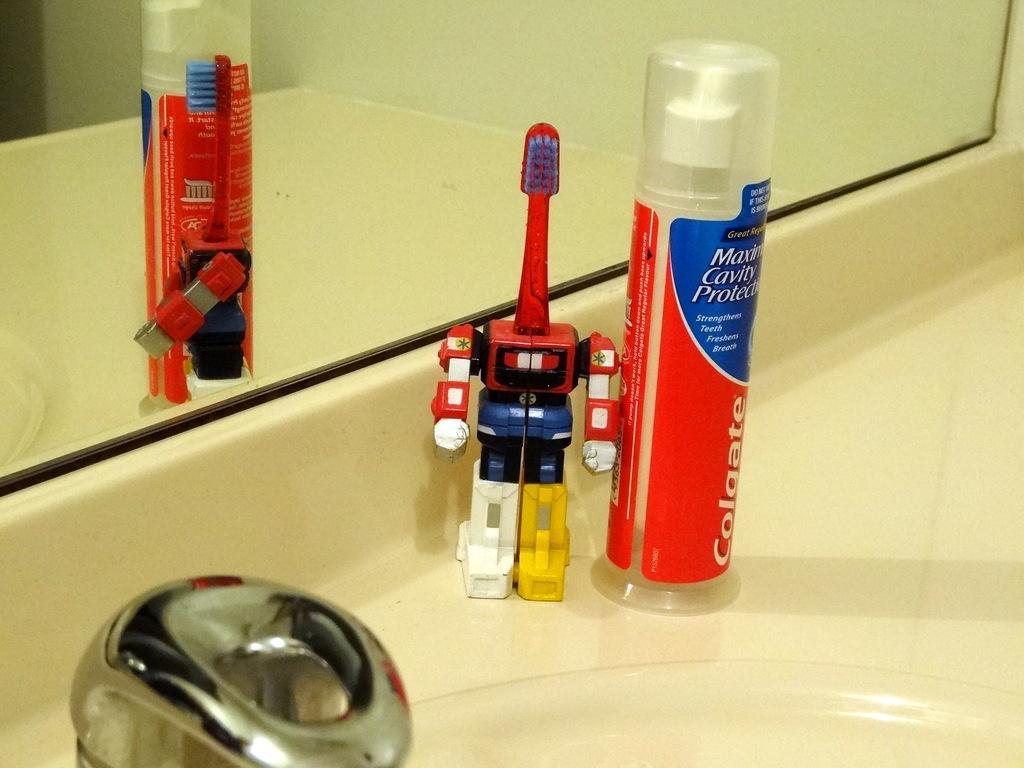What is the brand name of the toothpaste in the red tube?
Provide a short and direct response. Colgate. How much cavity protection is there?
Your answer should be compact. Maximum. 